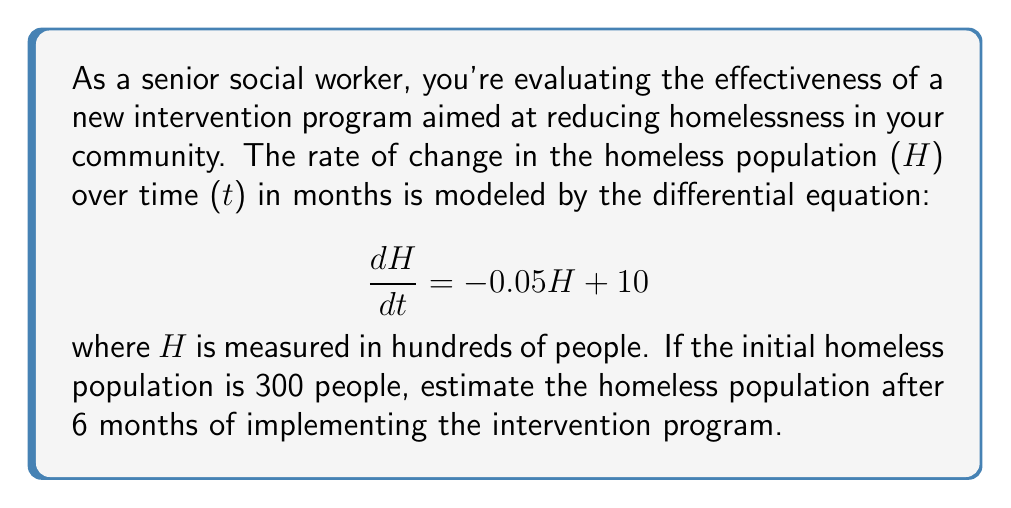Solve this math problem. To solve this problem, we need to follow these steps:

1) First, we recognize this as a first-order linear differential equation in the form:

   $$\frac{dH}{dt} + 0.05H = 10$$

2) The general solution for this type of equation is:

   $$H(t) = ce^{-0.05t} + 200$$

   where $c$ is a constant we need to determine using the initial condition.

3) We're given that initially (at $t=0$), $H = 300$ people, or 3 hundred. Let's use this to find $c$:

   $$3 = ce^{-0.05(0)} + 2$$
   $$3 = c + 2$$
   $$c = 1$$

4) Now we have our particular solution:

   $$H(t) = e^{-0.05t} + 200$$

5) To find $H$ after 6 months, we substitute $t=6$:

   $$H(6) = e^{-0.05(6)} + 200$$
   $$H(6) = e^{-0.3} + 200$$
   $$H(6) \approx 0.7408 + 200 = 200.7408$$

6) Remember, $H$ is measured in hundreds, so we multiply by 100:

   $$H(6) \approx 200.7408 * 100 = 20074.08$$

Therefore, after 6 months, the estimated homeless population is approximately 20,074 people.
Answer: 20,074 people 